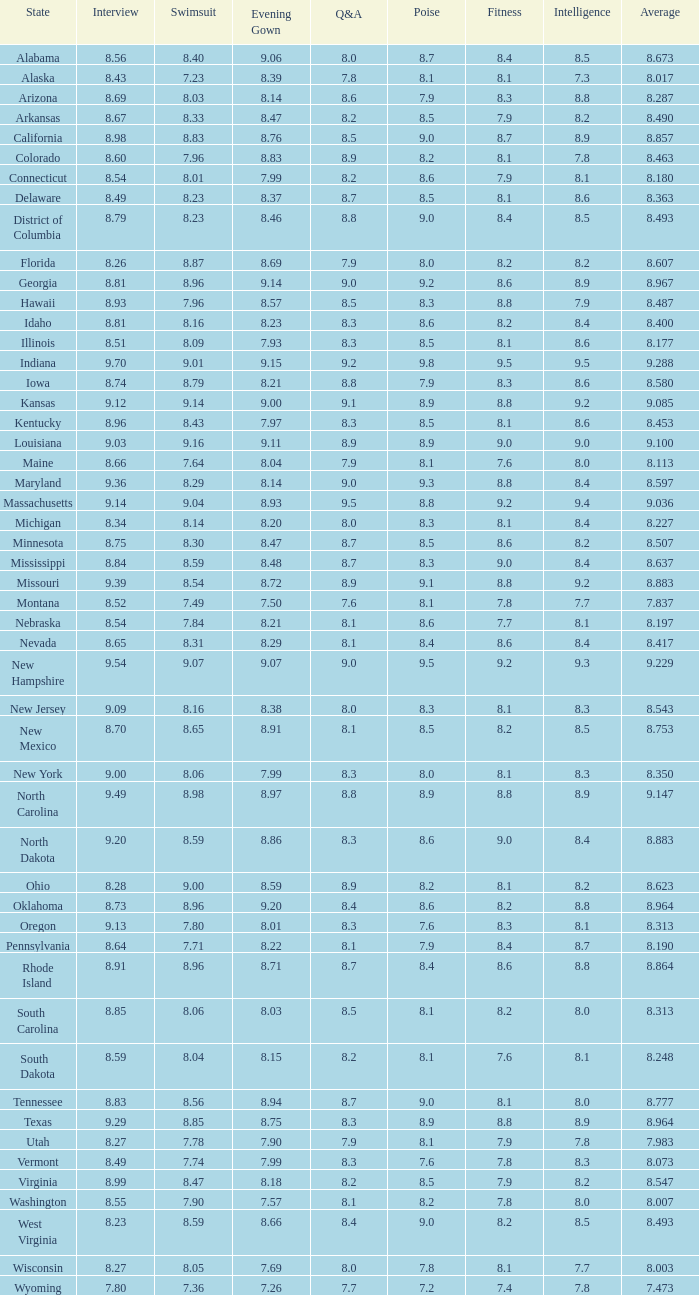Name the total number of swimsuits for evening gowns less than 8.21 and average of 8.453 with interview less than 9.09 1.0. 